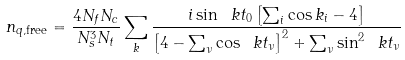Convert formula to latex. <formula><loc_0><loc_0><loc_500><loc_500>n _ { q , \text {free} } = \frac { 4 N _ { f } N _ { c } } { N _ { s } ^ { 3 } N _ { t } } \sum _ { k } { \frac { i \sin \ k t _ { 0 } \left [ \sum _ { i } \cos k _ { i } - 4 \right ] } { \left [ 4 - \sum _ { \nu } \cos \ k t _ { \nu } \right ] ^ { 2 } + \sum _ { \nu } \sin ^ { 2 } \ k t _ { \nu } } }</formula> 